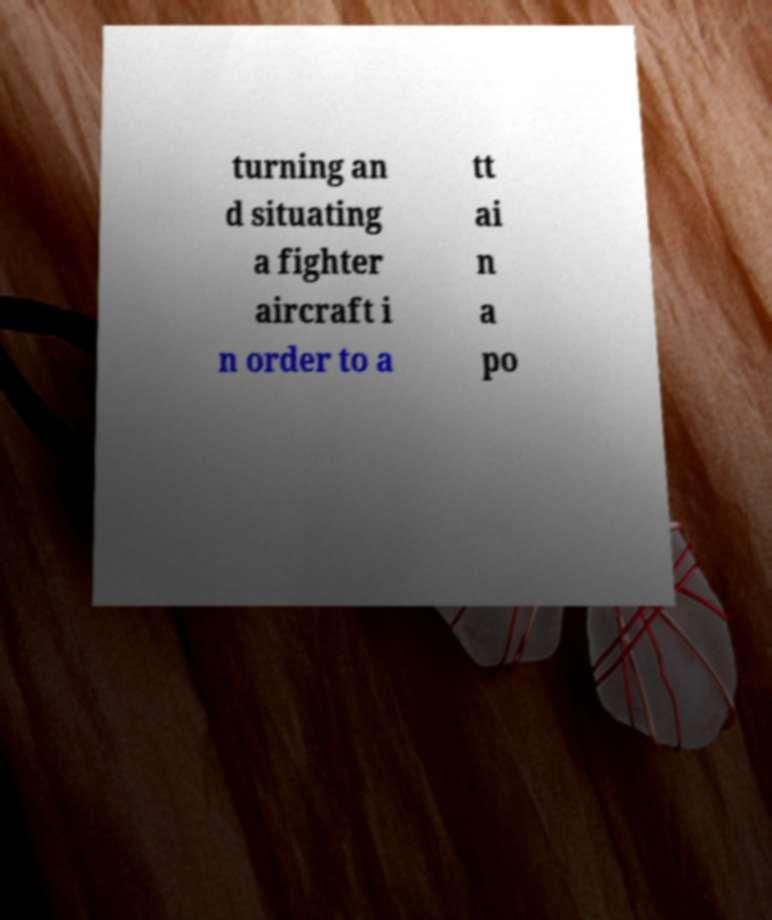What messages or text are displayed in this image? I need them in a readable, typed format. turning an d situating a fighter aircraft i n order to a tt ai n a po 